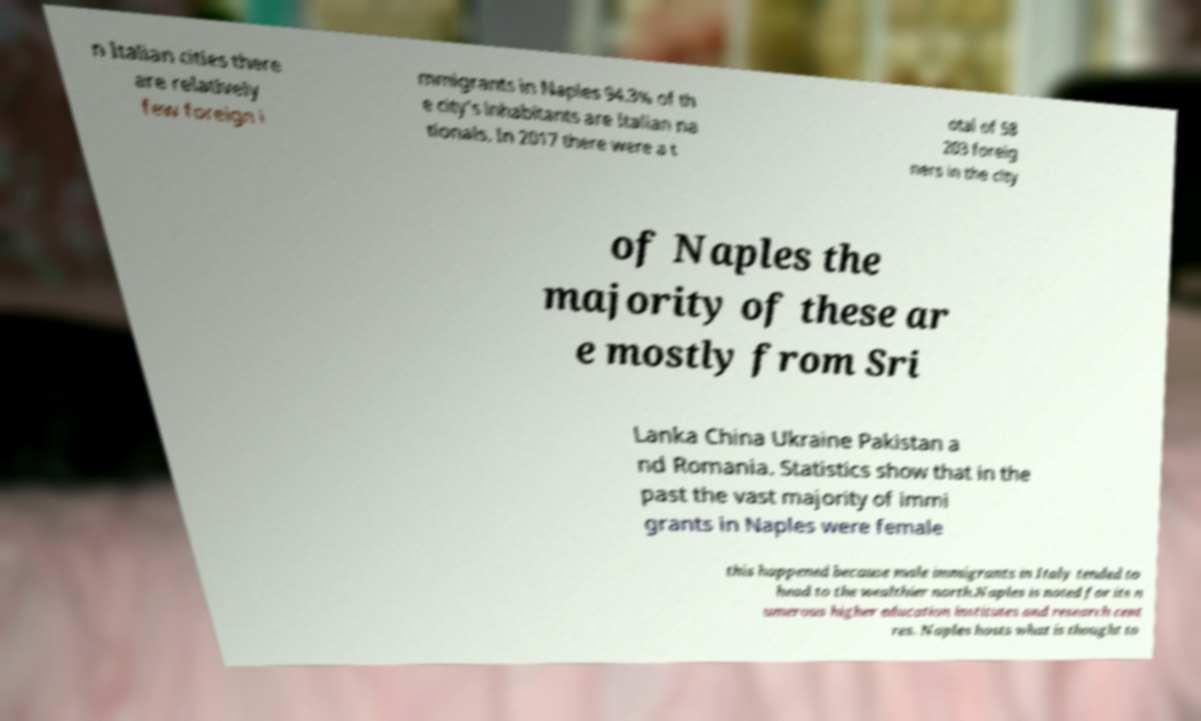For documentation purposes, I need the text within this image transcribed. Could you provide that? n Italian cities there are relatively few foreign i mmigrants in Naples 94.3% of th e city's inhabitants are Italian na tionals. In 2017 there were a t otal of 58 203 foreig ners in the city of Naples the majority of these ar e mostly from Sri Lanka China Ukraine Pakistan a nd Romania. Statistics show that in the past the vast majority of immi grants in Naples were female this happened because male immigrants in Italy tended to head to the wealthier north.Naples is noted for its n umerous higher education institutes and research cent res. Naples hosts what is thought to 